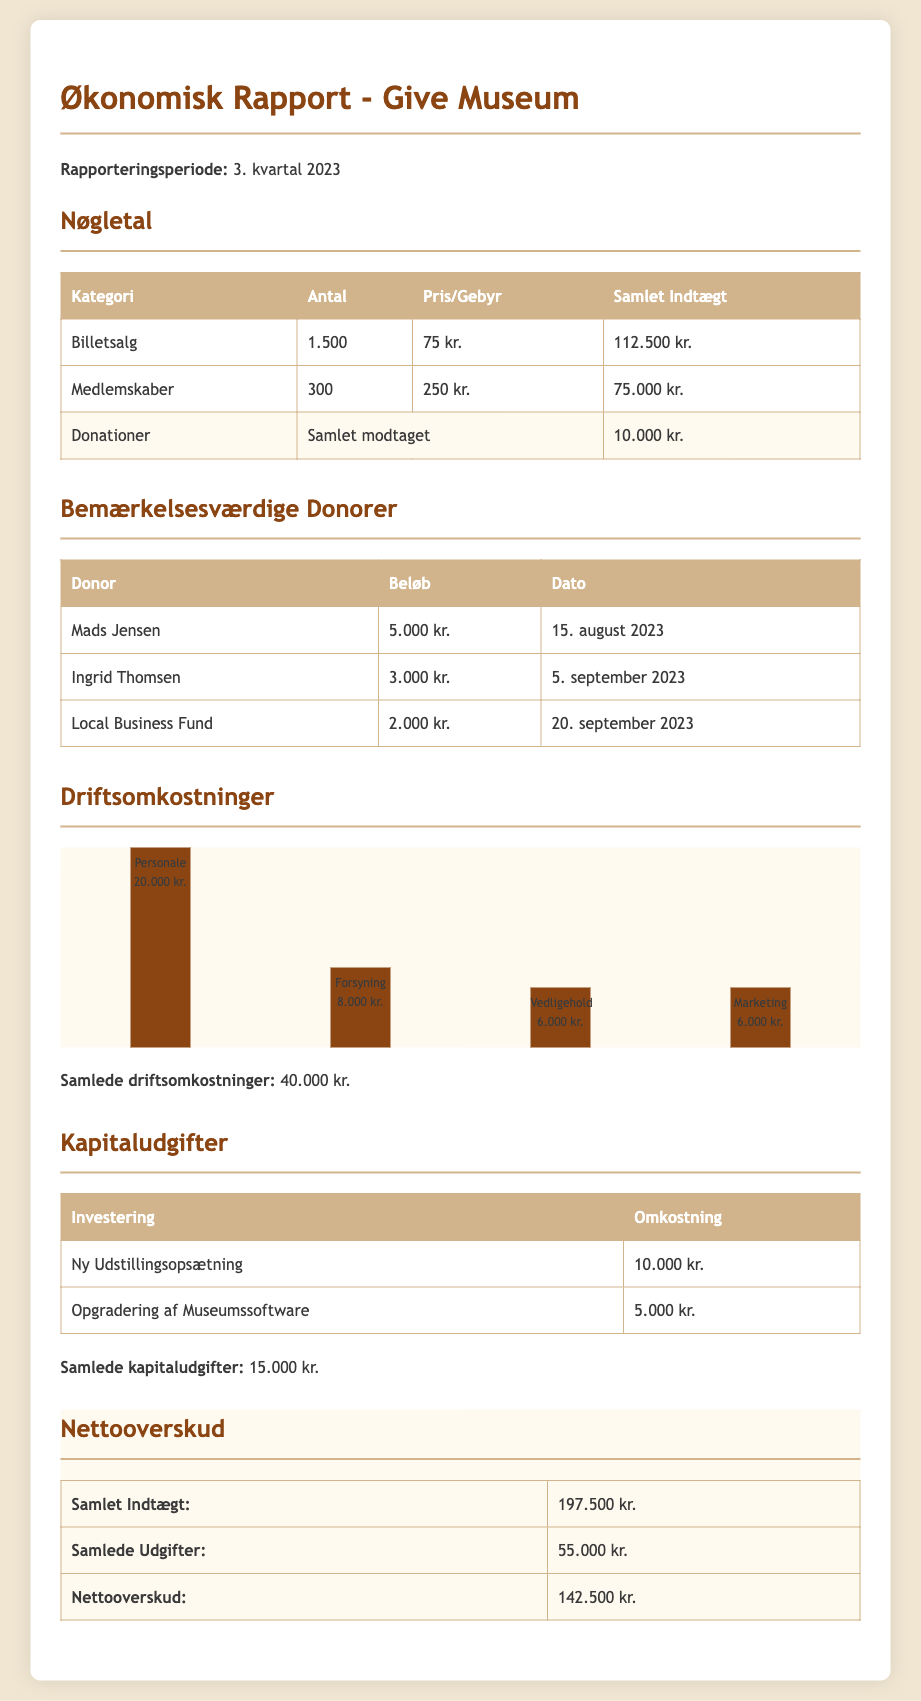what was the total ticket sales? The total ticket sales are calculated by multiplying the number of tickets sold (1500) by the price per ticket (75 kr.), which gives 112.500 kr.
Answer: 112.500 kr what is the total membership fee collected? The total membership fee collected is calculated by multiplying the number of memberships (300) by the price per membership (250 kr.), resulting in 75.000 kr.
Answer: 75.000 kr how much was donated in total? The total amount donated is explicitly stated in the document, which is 10.000 kr.
Answer: 10.000 kr who donated the highest amount? The highest donation is from Mads Jensen, who donated 5.000 kr. on 15. august 2023.
Answer: Mads Jensen what are the total operational costs? The total operational costs are given as the sum of all expenses listed under the operational costs section, totaling 40.000 kr.
Answer: 40.000 kr what was the total for capital expenditures? The total for capital expenditures is explicitly stated as 15.000 kr., calculated from the two investments listed.
Answer: 15.000 kr what is the net surplus for the quarter? The net surplus is calculated as total income (197.500 kr.) minus total expenses (55.000 kr.), which gives a net surplus of 142.500 kr.
Answer: 142.500 kr how many members does the museum have? The number of members is listed as 300 in the memberships category.
Answer: 300 how many notable donors were mentioned? The document lists three notable donors in the donations section.
Answer: 3 